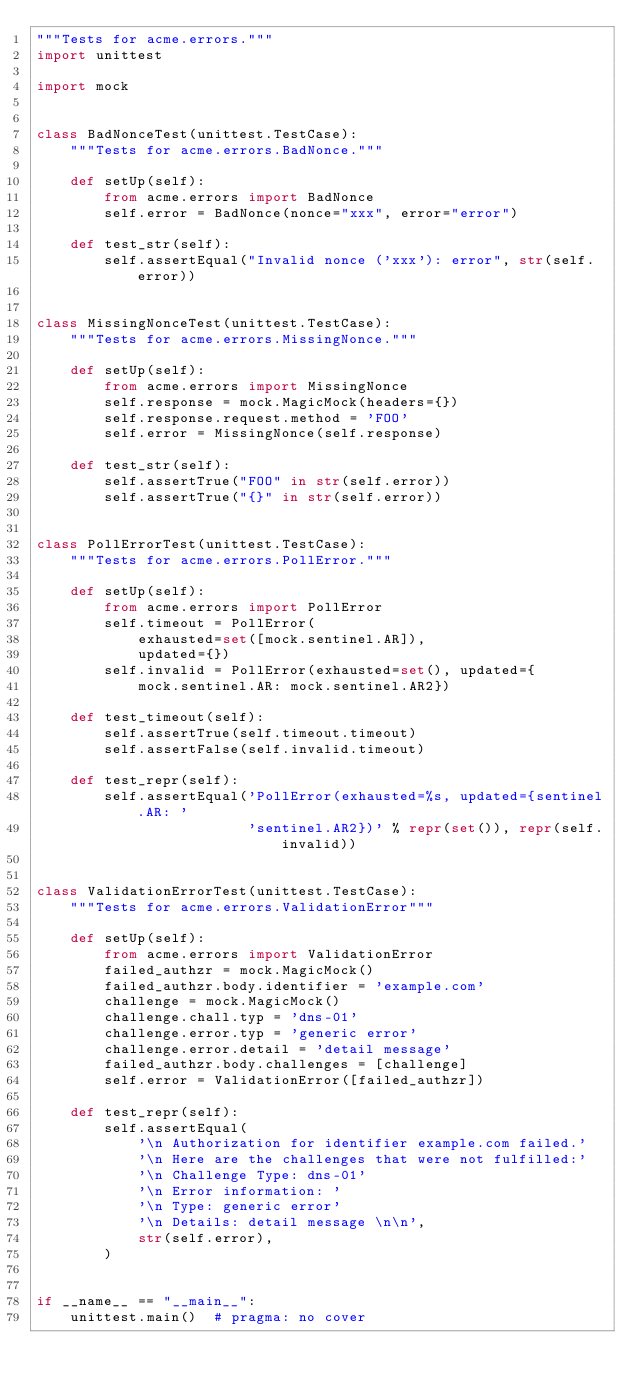<code> <loc_0><loc_0><loc_500><loc_500><_Python_>"""Tests for acme.errors."""
import unittest

import mock


class BadNonceTest(unittest.TestCase):
    """Tests for acme.errors.BadNonce."""

    def setUp(self):
        from acme.errors import BadNonce
        self.error = BadNonce(nonce="xxx", error="error")

    def test_str(self):
        self.assertEqual("Invalid nonce ('xxx'): error", str(self.error))


class MissingNonceTest(unittest.TestCase):
    """Tests for acme.errors.MissingNonce."""

    def setUp(self):
        from acme.errors import MissingNonce
        self.response = mock.MagicMock(headers={})
        self.response.request.method = 'FOO'
        self.error = MissingNonce(self.response)

    def test_str(self):
        self.assertTrue("FOO" in str(self.error))
        self.assertTrue("{}" in str(self.error))


class PollErrorTest(unittest.TestCase):
    """Tests for acme.errors.PollError."""

    def setUp(self):
        from acme.errors import PollError
        self.timeout = PollError(
            exhausted=set([mock.sentinel.AR]),
            updated={})
        self.invalid = PollError(exhausted=set(), updated={
            mock.sentinel.AR: mock.sentinel.AR2})

    def test_timeout(self):
        self.assertTrue(self.timeout.timeout)
        self.assertFalse(self.invalid.timeout)

    def test_repr(self):
        self.assertEqual('PollError(exhausted=%s, updated={sentinel.AR: '
                         'sentinel.AR2})' % repr(set()), repr(self.invalid))


class ValidationErrorTest(unittest.TestCase):
    """Tests for acme.errors.ValidationError"""

    def setUp(self):
        from acme.errors import ValidationError
        failed_authzr = mock.MagicMock()
        failed_authzr.body.identifier = 'example.com'
        challenge = mock.MagicMock()
        challenge.chall.typ = 'dns-01'
        challenge.error.typ = 'generic error'
        challenge.error.detail = 'detail message'
        failed_authzr.body.challenges = [challenge]
        self.error = ValidationError([failed_authzr])

    def test_repr(self):
        self.assertEqual(
            '\n Authorization for identifier example.com failed.'
            '\n Here are the challenges that were not fulfilled:'
            '\n Challenge Type: dns-01'
            '\n Error information: '
            '\n Type: generic error'
            '\n Details: detail message \n\n',
            str(self.error),
        )


if __name__ == "__main__":
    unittest.main()  # pragma: no cover
</code> 